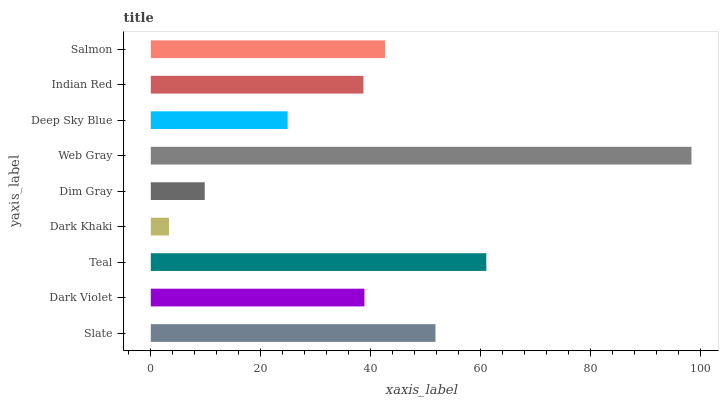Is Dark Khaki the minimum?
Answer yes or no. Yes. Is Web Gray the maximum?
Answer yes or no. Yes. Is Dark Violet the minimum?
Answer yes or no. No. Is Dark Violet the maximum?
Answer yes or no. No. Is Slate greater than Dark Violet?
Answer yes or no. Yes. Is Dark Violet less than Slate?
Answer yes or no. Yes. Is Dark Violet greater than Slate?
Answer yes or no. No. Is Slate less than Dark Violet?
Answer yes or no. No. Is Dark Violet the high median?
Answer yes or no. Yes. Is Dark Violet the low median?
Answer yes or no. Yes. Is Dark Khaki the high median?
Answer yes or no. No. Is Deep Sky Blue the low median?
Answer yes or no. No. 